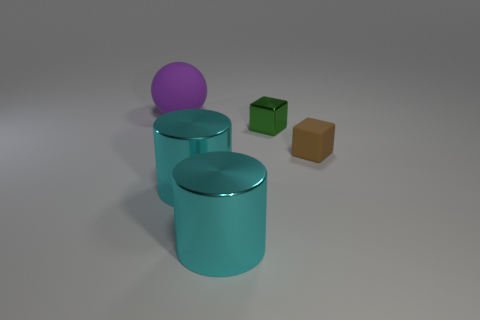Add 2 big yellow metallic objects. How many objects exist? 7 Subtract all spheres. How many objects are left? 4 Add 1 large cylinders. How many large cylinders are left? 3 Add 5 big red rubber things. How many big red rubber things exist? 5 Subtract 0 yellow cubes. How many objects are left? 5 Subtract all tiny green cubes. Subtract all tiny green metal cylinders. How many objects are left? 4 